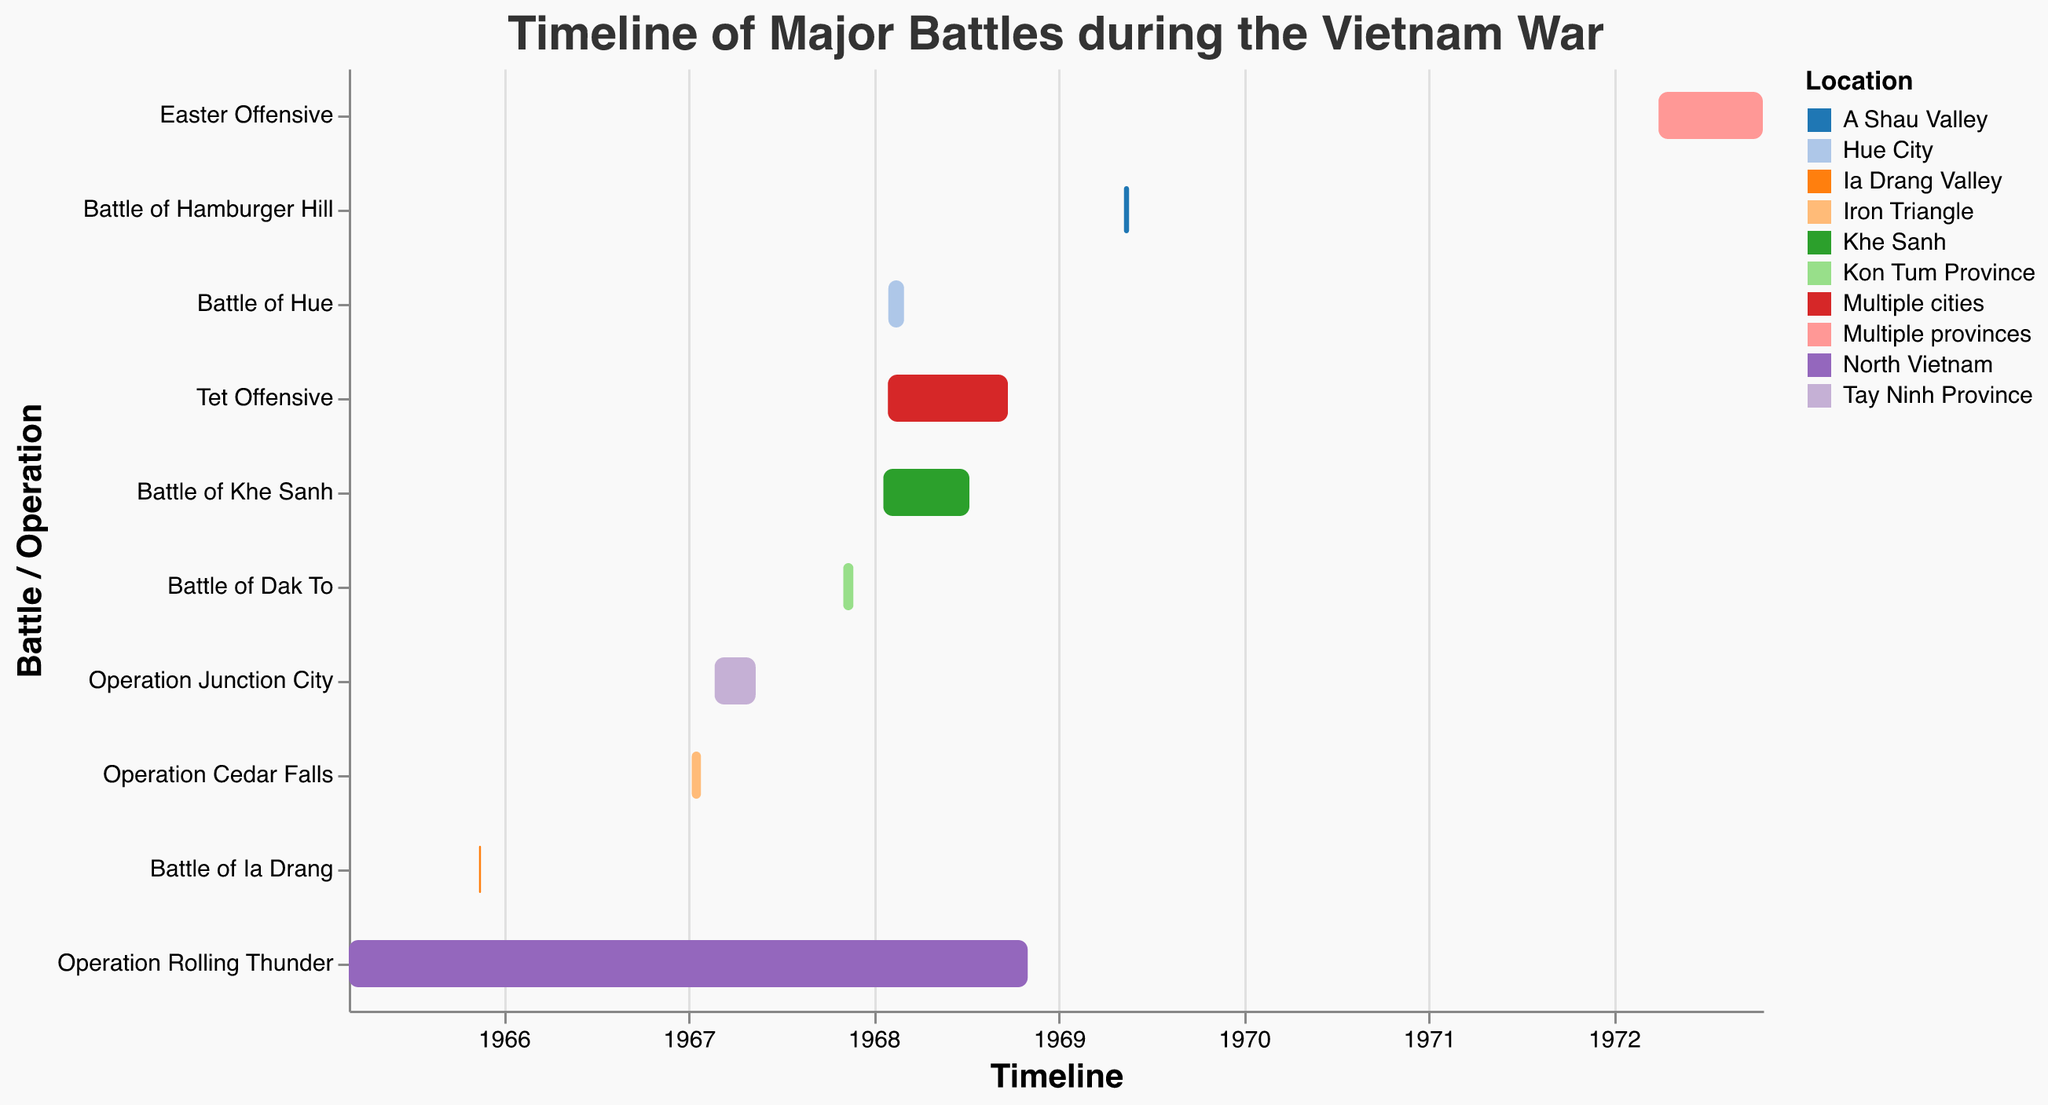What is the title of the Gantt chart? The title of the Gantt Chart is positioned at the top of the figure and usually describes the content of the chart.
Answer: Timeline of Major Battles during the Vietnam War Which battle lasted the longest, and how long did it last? To determine the longest duration, look at the time length of each bar in the Gantt chart. The Tet Offensive, lasting from January 30, 1968, to September 23, 1968, has the longest duration.
Answer: Tet Offensive, approximately 8 months What are the start and end dates of the Battle of Khe Sanh? Locate the bar labeled "Battle of Khe Sanh" and check the start and end points on the x-axis.
Answer: January 21, 1968 - July 9, 1968 Which battle or operation had the shortest duration? By examining the length of each bar, the shortest duration is the Operation Cedar Falls, which lasted from January 8, 1967, to January 26, 1967.
Answer: Operation Cedar Falls How many battles took place in 1967? Identify the battles that have either their start or end date in 1967. There are four: Operation Cedar Falls, Operation Junction City, Battle of Dak To, and Operation Rolling Thunder.
Answer: Four How many battles or operations had their start date in 1968? Examine the starting points of the bars to see which ones begin in 1968. There are three: Tet Offensive, Battle of Khe Sanh, and Battle of Hue.
Answer: Three Which battles or operations occurred in multiple cities or provinces? Look for bars labeled as happening in "Multiple cities" or "Multiple provinces": Tet Offensive and Easter Offensive.
Answer: Tet Offensive, Easter Offensive During which operation did the Battle of Hue occur? The Battle of Hue took place during the Tet Offensive, indicated by overlapping timelines and locations detailed on the chart.
Answer: Tet Offensive Was the Battle of Dak To longer or shorter than the Battle of Hamburger Hill? Compare the lengths of the bars for Battle of Dak To and Battle of Hamburger Hill to determine their relative durations. The Battle of Dak To (November 3, 1967 - November 23, 1967) was longer.
Answer: Battle of Dak To was longer Which battle or operation took place in A Shau Valley? Locate the location label associated with A Shau Valley on the y-axis, which corresponds to the Battle of Hamburger Hill.
Answer: Battle of Hamburger Hill 